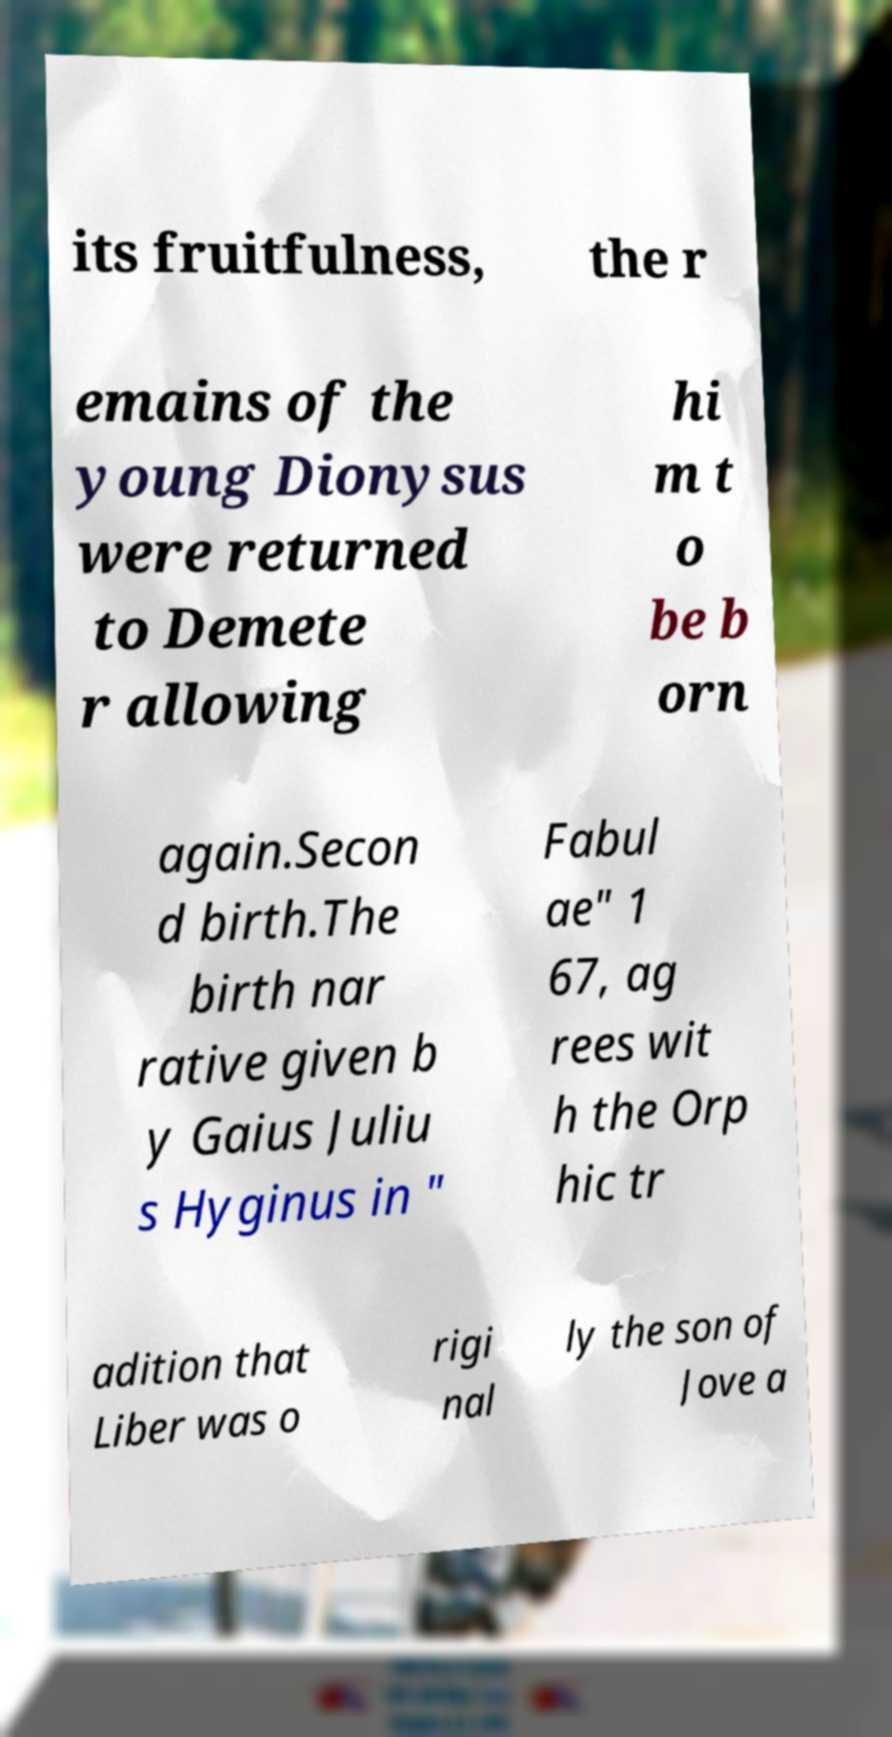Please read and relay the text visible in this image. What does it say? its fruitfulness, the r emains of the young Dionysus were returned to Demete r allowing hi m t o be b orn again.Secon d birth.The birth nar rative given b y Gaius Juliu s Hyginus in " Fabul ae" 1 67, ag rees wit h the Orp hic tr adition that Liber was o rigi nal ly the son of Jove a 